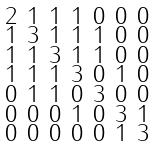<formula> <loc_0><loc_0><loc_500><loc_500>\begin{smallmatrix} 2 & 1 & 1 & 1 & 0 & 0 & 0 \\ 1 & 3 & 1 & 1 & 1 & 0 & 0 \\ 1 & 1 & 3 & 1 & 1 & 0 & 0 \\ 1 & 1 & 1 & 3 & 0 & 1 & 0 \\ 0 & 1 & 1 & 0 & 3 & 0 & 0 \\ 0 & 0 & 0 & 1 & 0 & 3 & 1 \\ 0 & 0 & 0 & 0 & 0 & 1 & 3 \end{smallmatrix}</formula> 